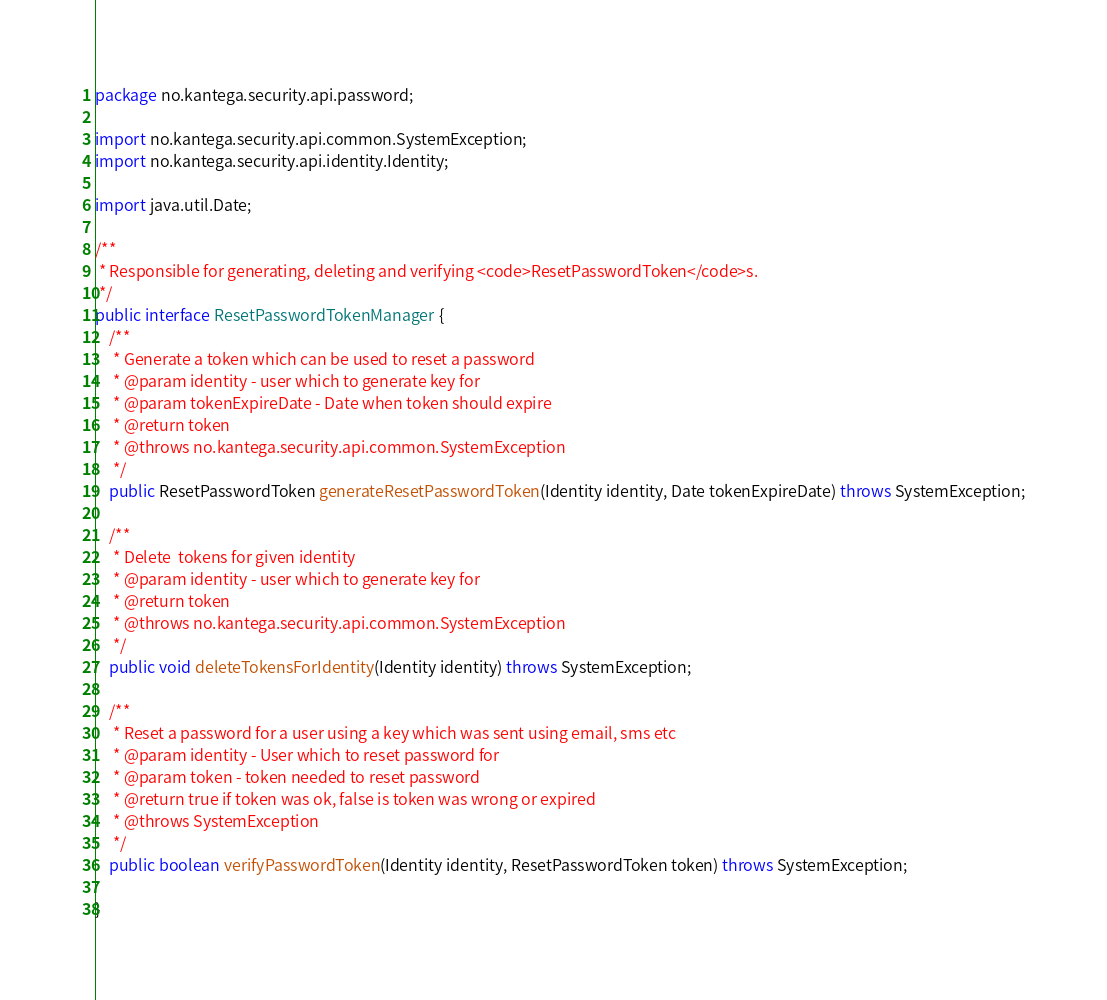<code> <loc_0><loc_0><loc_500><loc_500><_Java_>package no.kantega.security.api.password;

import no.kantega.security.api.common.SystemException;
import no.kantega.security.api.identity.Identity;

import java.util.Date;

/**
 * Responsible for generating, deleting and verifying <code>ResetPasswordToken</code>s.
 */
public interface ResetPasswordTokenManager {
    /**
     * Generate a token which can be used to reset a password
     * @param identity - user which to generate key for
     * @param tokenExpireDate - Date when token should expire
     * @return token
     * @throws no.kantega.security.api.common.SystemException
     */
    public ResetPasswordToken generateResetPasswordToken(Identity identity, Date tokenExpireDate) throws SystemException;

    /**
     * Delete  tokens for given identity
     * @param identity - user which to generate key for
     * @return token
     * @throws no.kantega.security.api.common.SystemException
     */
    public void deleteTokensForIdentity(Identity identity) throws SystemException;

    /**
     * Reset a password for a user using a key which was sent using email, sms etc
     * @param identity - User which to reset password for
     * @param token - token needed to reset password
     * @return true if token was ok, false is token was wrong or expired
     * @throws SystemException
     */
    public boolean verifyPasswordToken(Identity identity, ResetPasswordToken token) throws SystemException;

}
</code> 